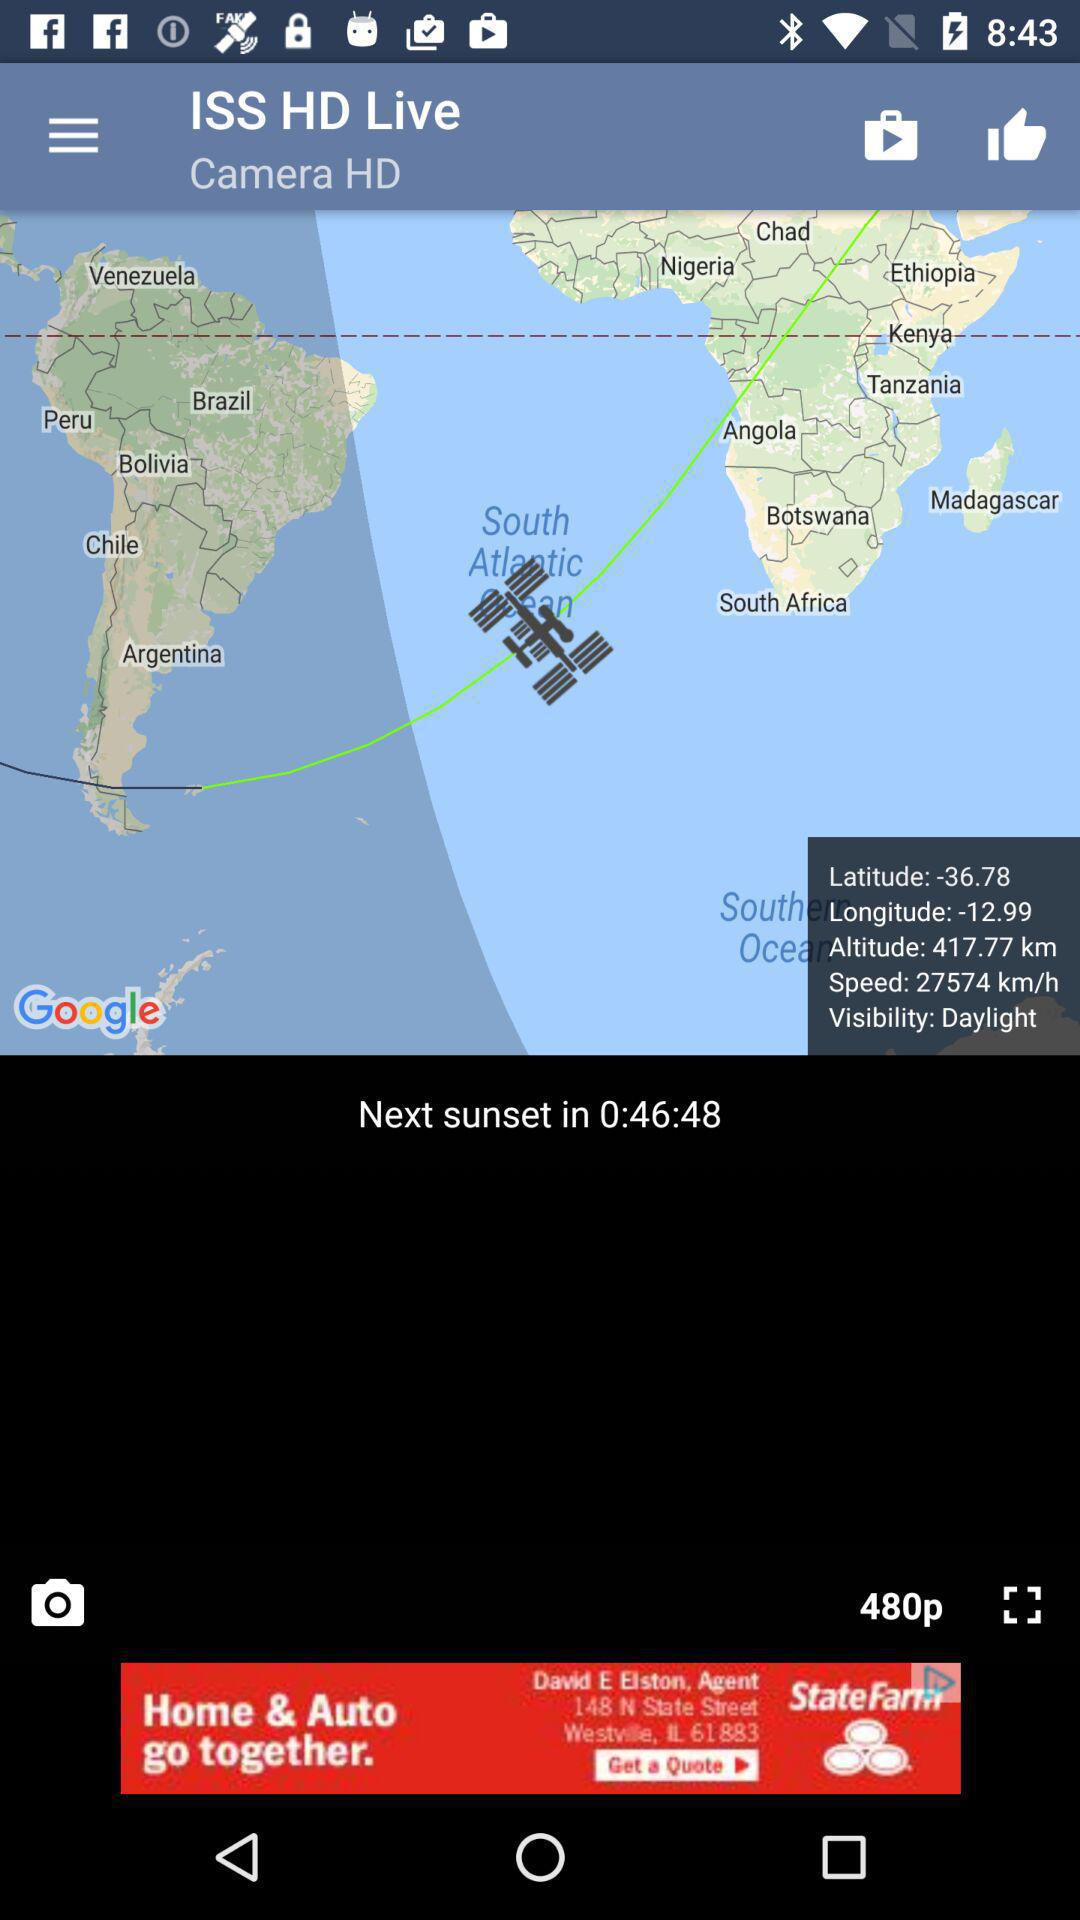How much time is left until the next sunset? The time left until the next sunset is 46 minutes 48 seconds. 